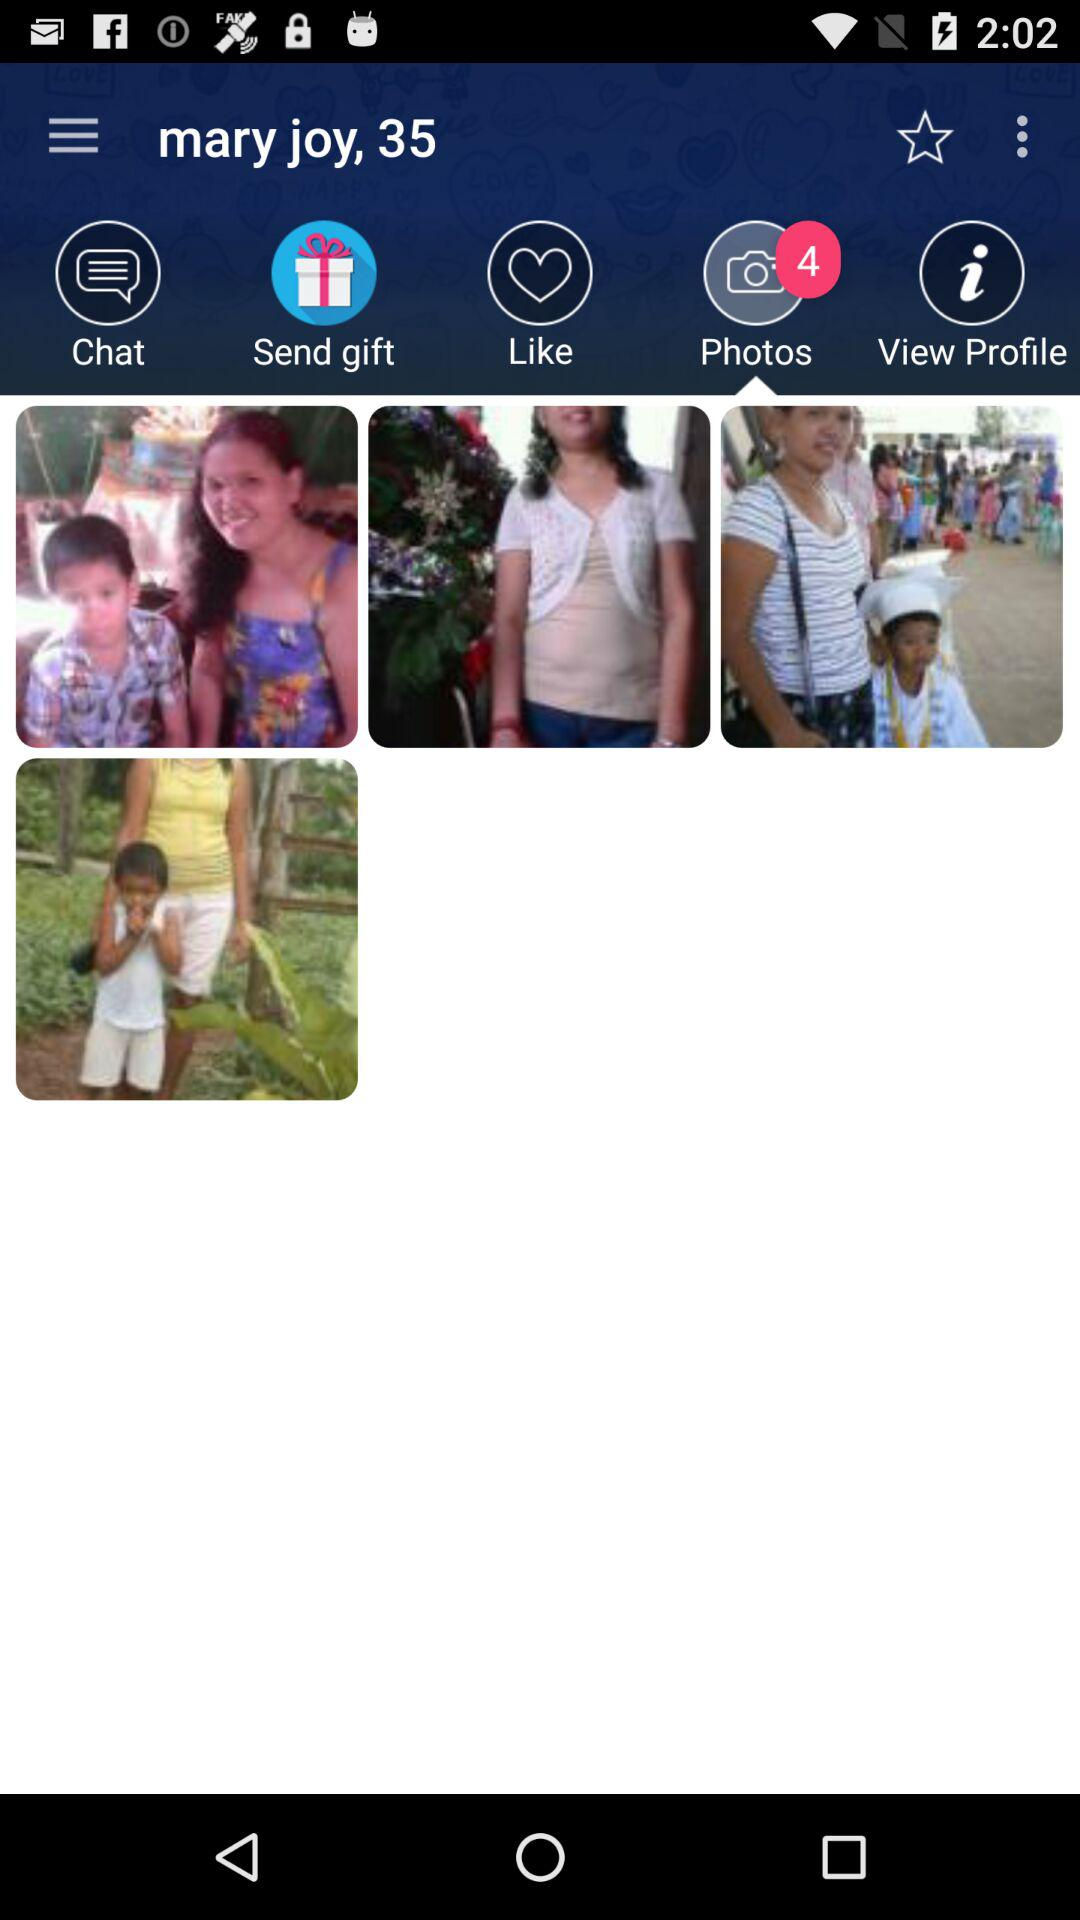What is the age? The age is 35. 